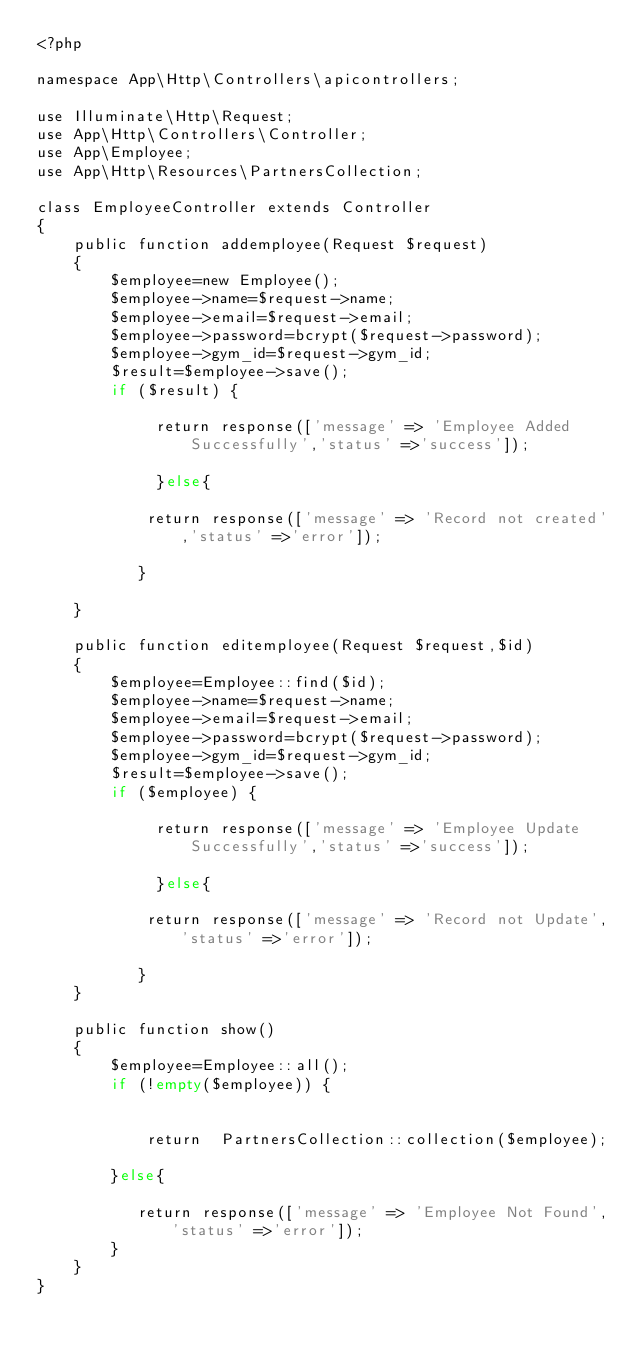Convert code to text. <code><loc_0><loc_0><loc_500><loc_500><_PHP_><?php

namespace App\Http\Controllers\apicontrollers;

use Illuminate\Http\Request;
use App\Http\Controllers\Controller;
use App\Employee;
use App\Http\Resources\PartnersCollection;

class EmployeeController extends Controller
{
    public function addemployee(Request $request)
    {
    	$employee=new Employee();
    	$employee->name=$request->name;
    	$employee->email=$request->email;
    	$employee->password=bcrypt($request->password);
    	$employee->gym_id=$request->gym_id;
    	$result=$employee->save();
    	if ($result) {

             return response(['message' => 'Employee Added Successfully','status' =>'success']);
            
             }else{

            return response(['message' => 'Record not created','status' =>'error']);
            
           }
    	
    }

    public function editemployee(Request $request,$id)
    {
    	$employee=Employee::find($id);
    	$employee->name=$request->name;
    	$employee->email=$request->email;
    	$employee->password=bcrypt($request->password);
    	$employee->gym_id=$request->gym_id;
    	$result=$employee->save();
    	if ($employee) {

             return response(['message' => 'Employee Update Successfully','status' =>'success']);
            
             }else{

            return response(['message' => 'Record not Update','status' =>'error']);
            
           }
    }

    public function show()
    {
        $employee=Employee::all();
        if (!empty($employee)) {


            return  PartnersCollection::collection($employee);

        }else{
            
           return response(['message' => 'Employee Not Found','status' =>'error']);
        }
    }
}
</code> 